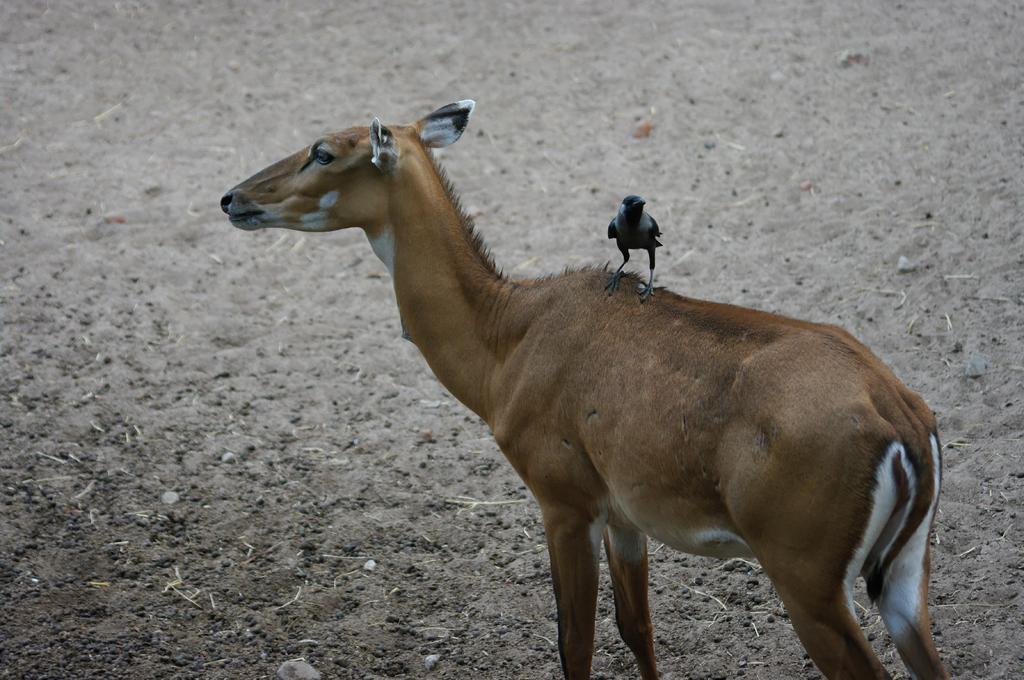What animal is the main subject of the image? There is a crow in the image. What is the crow doing in the image? The crow is on a deer. What type of terrain can be seen in the background of the image? There is ground visible in the background of the image. What type of insurance does the crow have in the image? There is no mention of insurance in the image, as it features a crow on a deer with a ground background. 